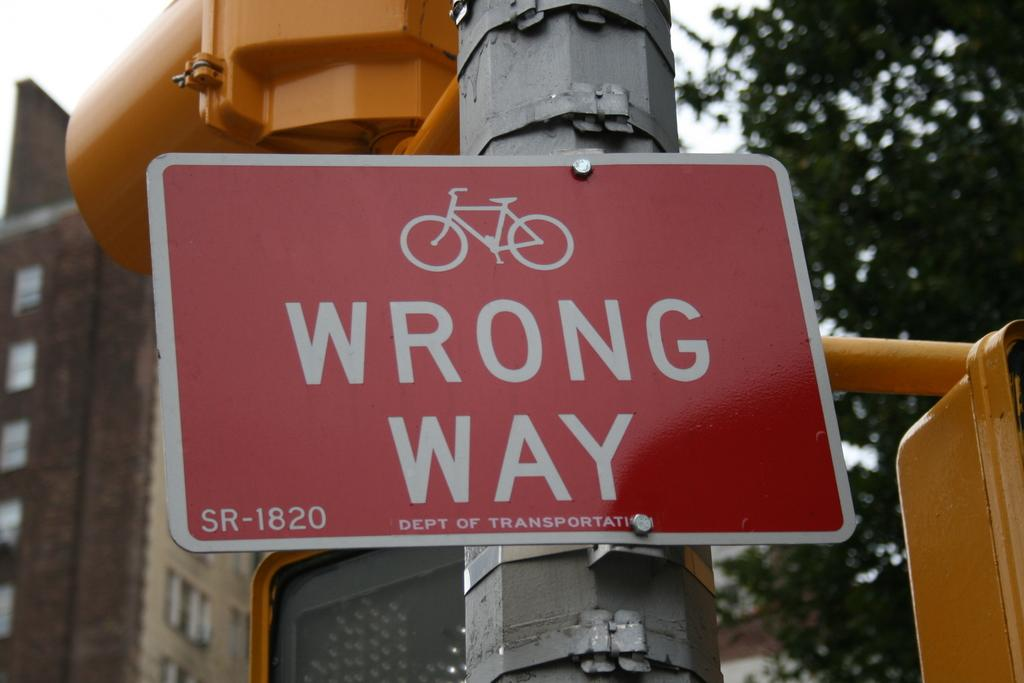What color is the boat in the image? The boat in the image is red. What is written on the boat? The boat has "wrong way" written on it. How is the boat positioned in the image? The boat is attached to a pole. What can be seen in the background of the image? There are trees and a building in the background of the image. Who is the partner of the boat in the image? There is no partner mentioned or depicted in the image; it only shows a red boat with "wrong way" written on it and attached to a pole. 